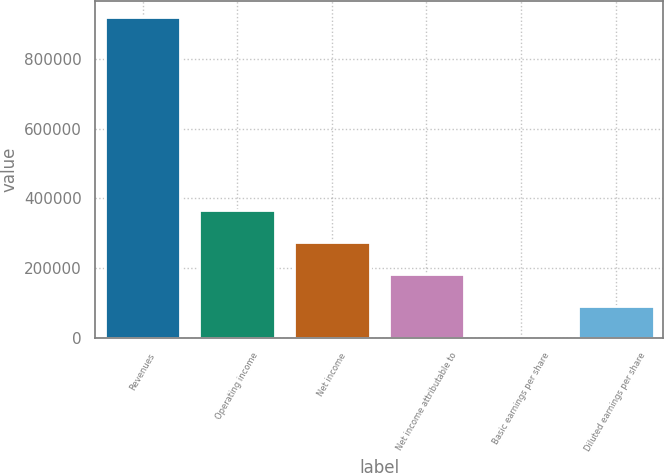<chart> <loc_0><loc_0><loc_500><loc_500><bar_chart><fcel>Revenues<fcel>Operating income<fcel>Net income<fcel>Net income attributable to<fcel>Basic earnings per share<fcel>Diluted earnings per share<nl><fcel>919762<fcel>367905<fcel>275929<fcel>183953<fcel>0.32<fcel>91976.5<nl></chart> 